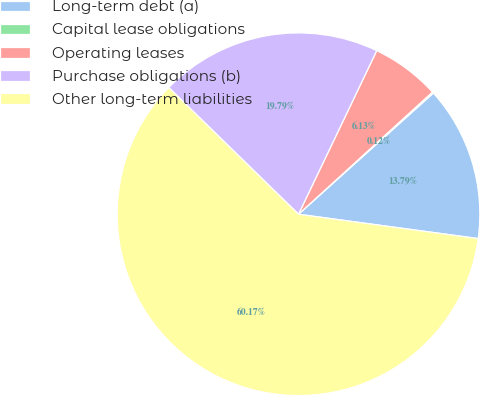<chart> <loc_0><loc_0><loc_500><loc_500><pie_chart><fcel>Long-term debt (a)<fcel>Capital lease obligations<fcel>Operating leases<fcel>Purchase obligations (b)<fcel>Other long-term liabilities<nl><fcel>13.79%<fcel>0.12%<fcel>6.13%<fcel>19.79%<fcel>60.16%<nl></chart> 